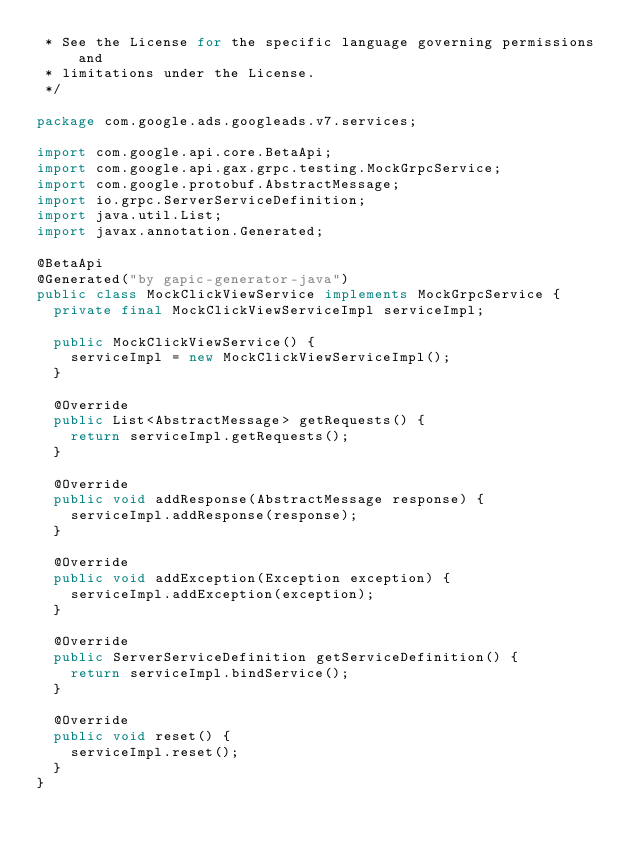Convert code to text. <code><loc_0><loc_0><loc_500><loc_500><_Java_> * See the License for the specific language governing permissions and
 * limitations under the License.
 */

package com.google.ads.googleads.v7.services;

import com.google.api.core.BetaApi;
import com.google.api.gax.grpc.testing.MockGrpcService;
import com.google.protobuf.AbstractMessage;
import io.grpc.ServerServiceDefinition;
import java.util.List;
import javax.annotation.Generated;

@BetaApi
@Generated("by gapic-generator-java")
public class MockClickViewService implements MockGrpcService {
  private final MockClickViewServiceImpl serviceImpl;

  public MockClickViewService() {
    serviceImpl = new MockClickViewServiceImpl();
  }

  @Override
  public List<AbstractMessage> getRequests() {
    return serviceImpl.getRequests();
  }

  @Override
  public void addResponse(AbstractMessage response) {
    serviceImpl.addResponse(response);
  }

  @Override
  public void addException(Exception exception) {
    serviceImpl.addException(exception);
  }

  @Override
  public ServerServiceDefinition getServiceDefinition() {
    return serviceImpl.bindService();
  }

  @Override
  public void reset() {
    serviceImpl.reset();
  }
}
</code> 